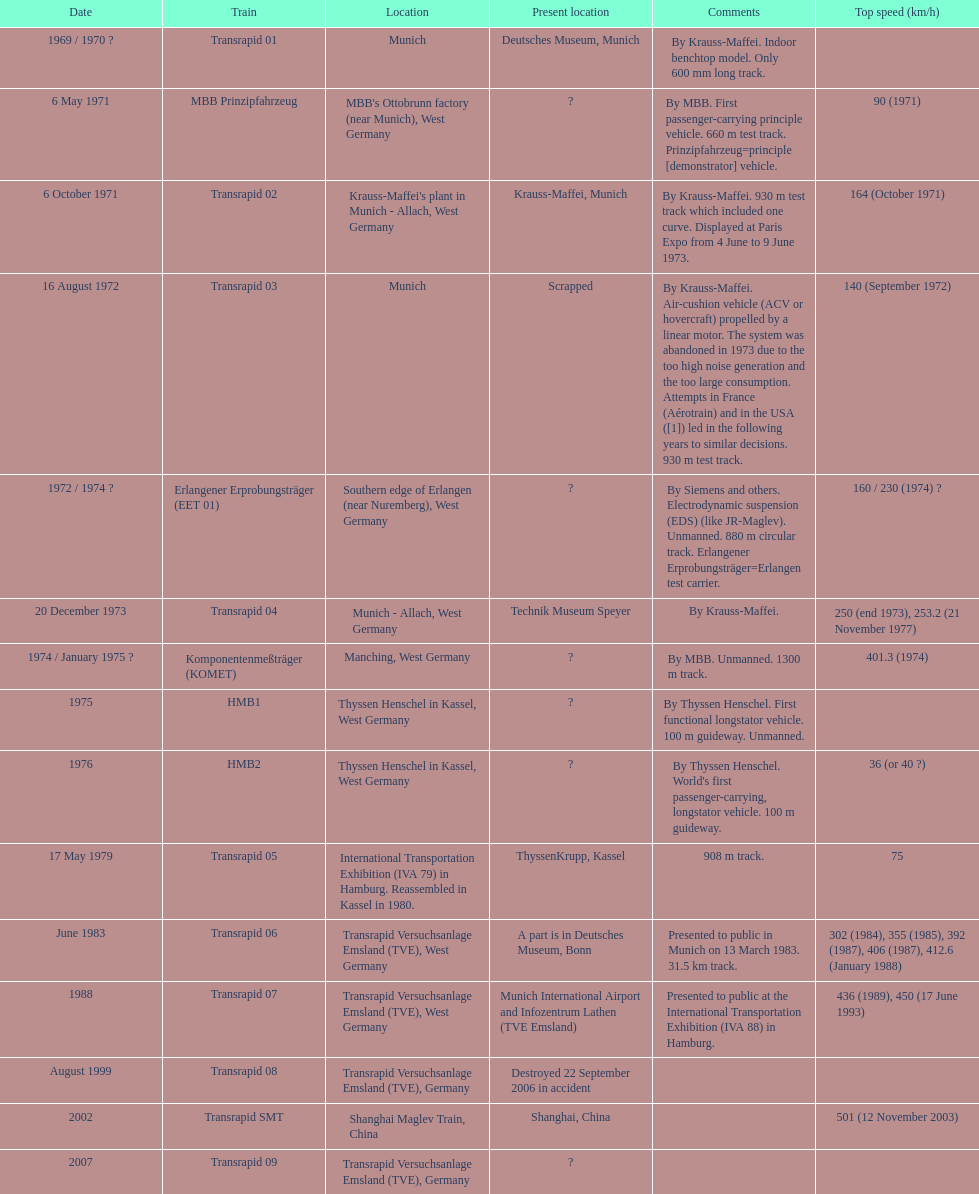Which train has the lowest maximum speed? HMB2. 